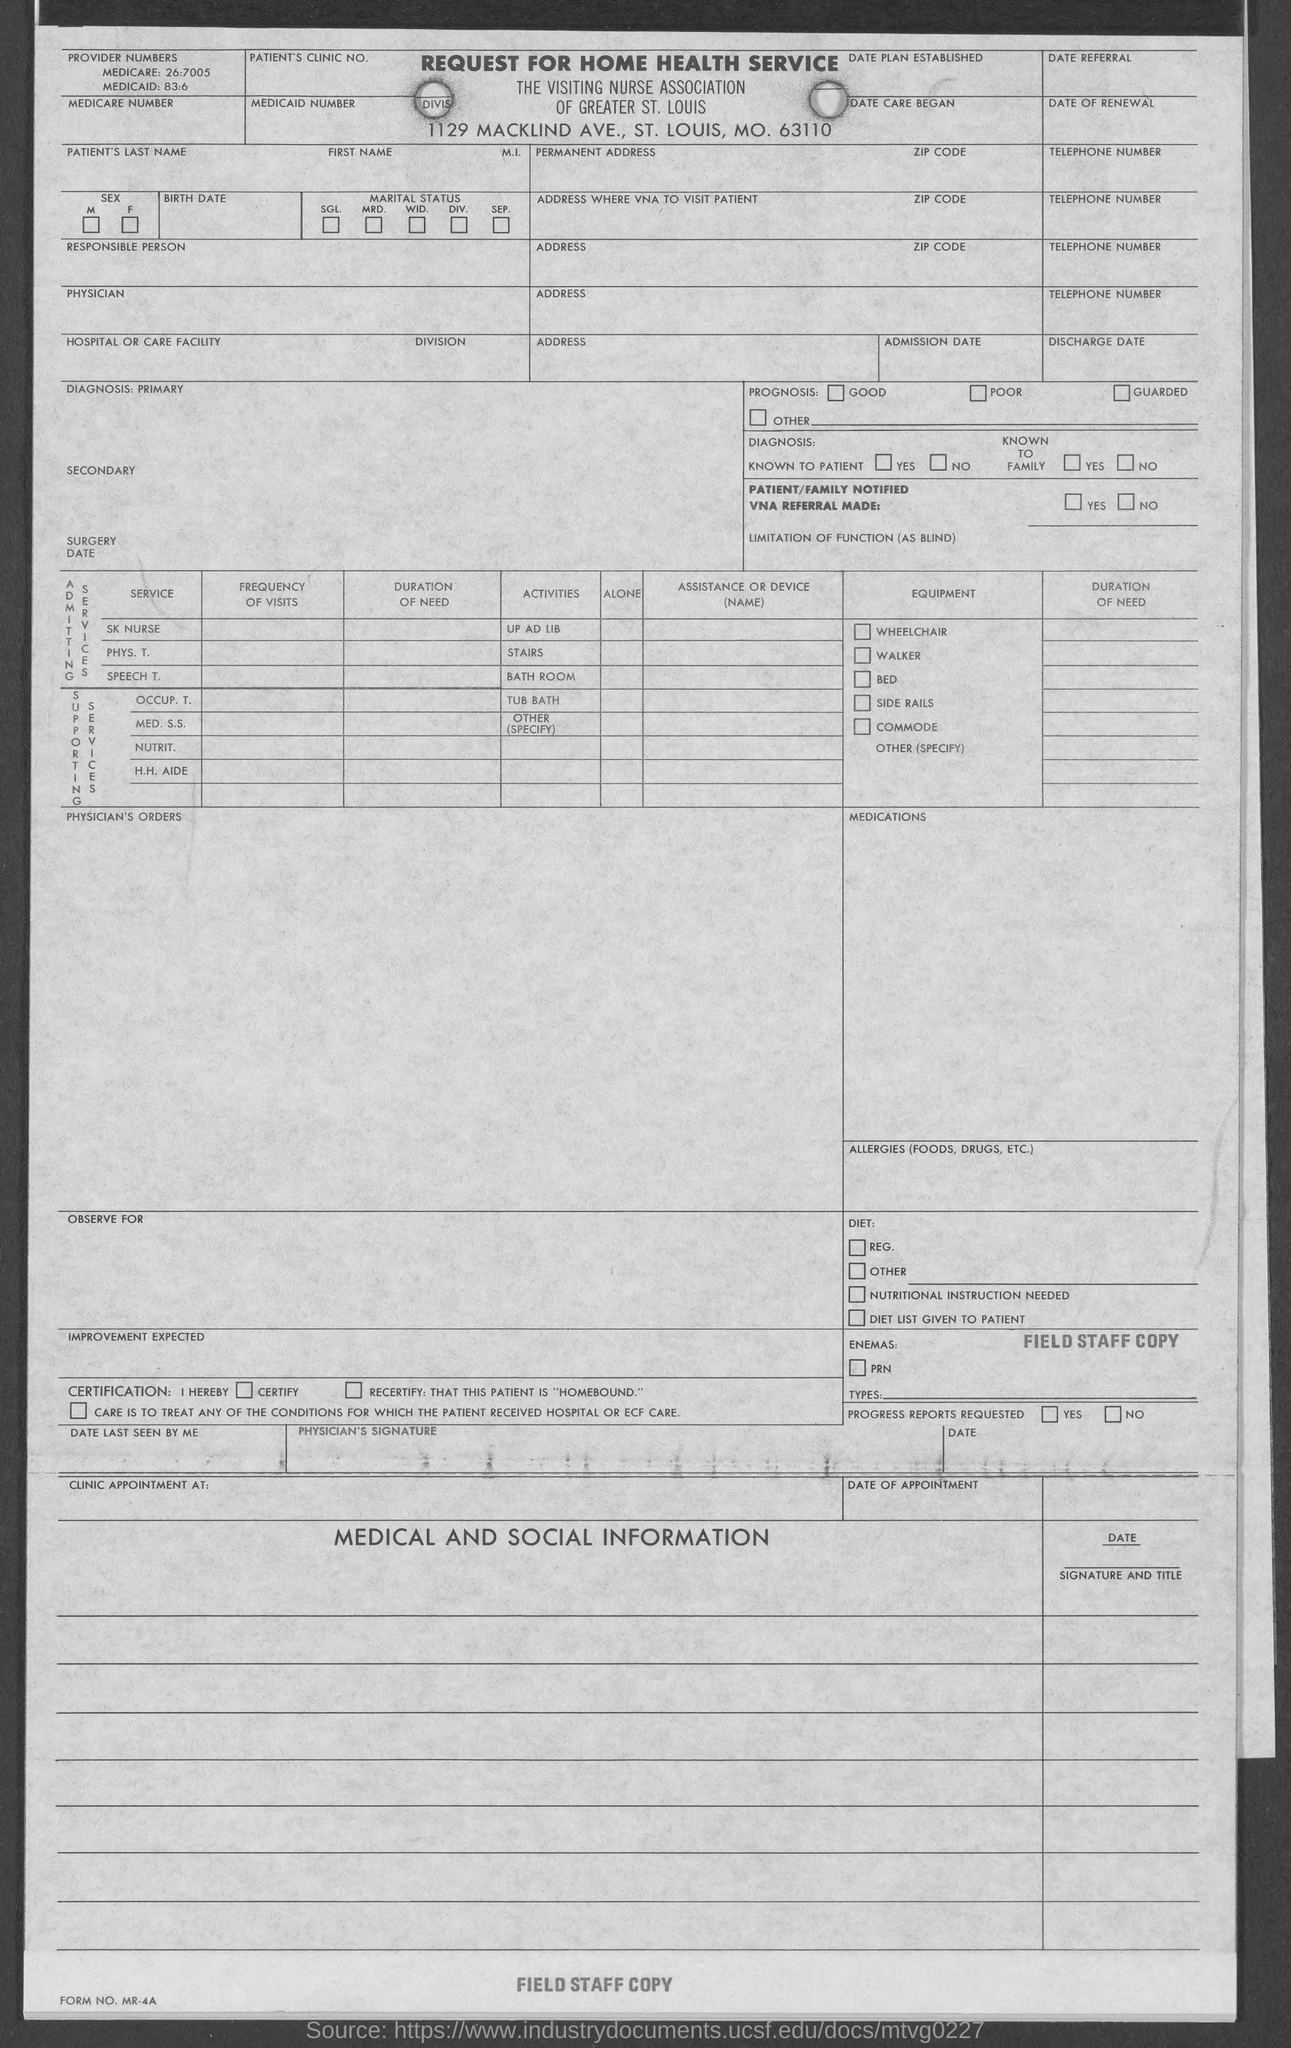Point out several critical features in this image. The Medicaid number mentioned in the given form is 83:6. The Medicare number provided in the given form is 26:7005. 